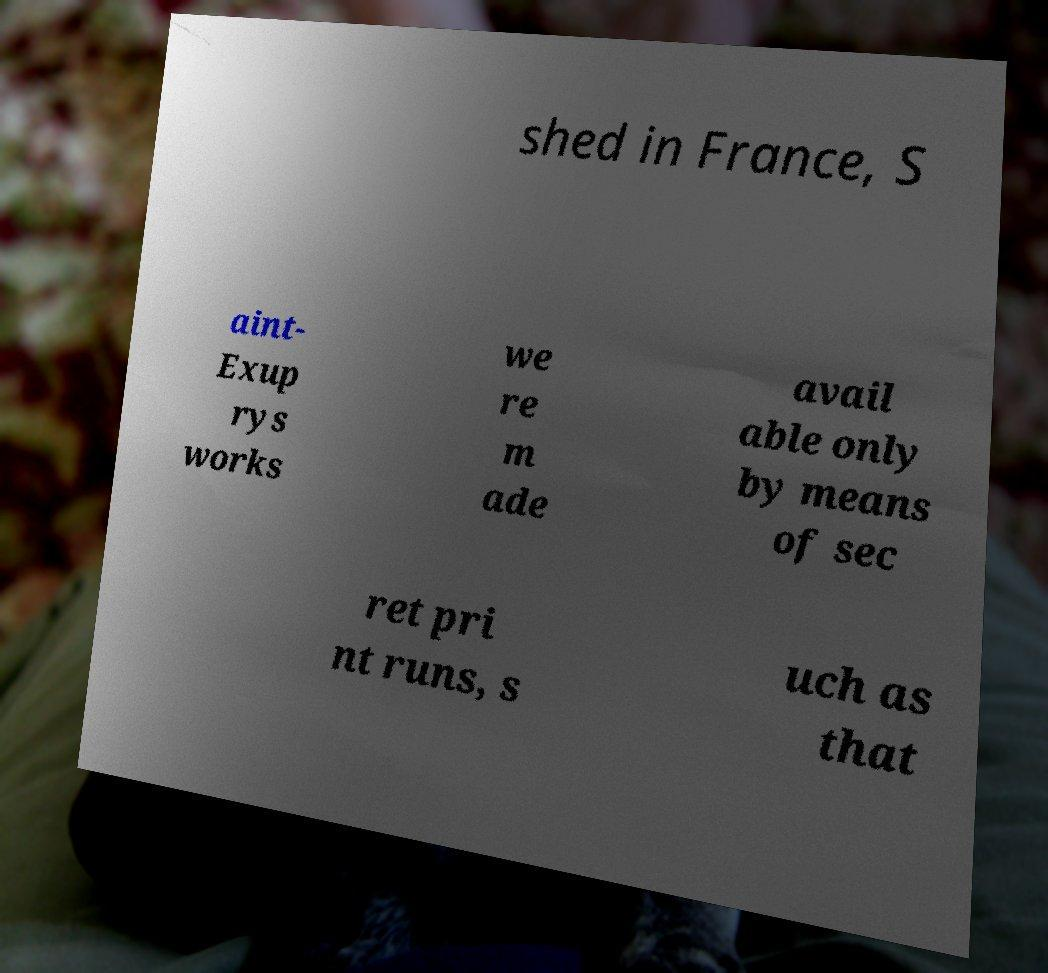Please identify and transcribe the text found in this image. shed in France, S aint- Exup rys works we re m ade avail able only by means of sec ret pri nt runs, s uch as that 